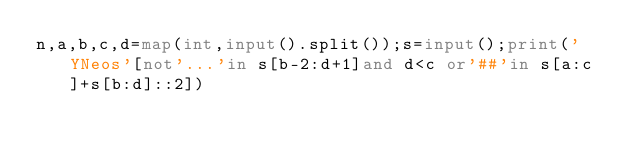Convert code to text. <code><loc_0><loc_0><loc_500><loc_500><_Python_>n,a,b,c,d=map(int,input().split());s=input();print('YNeos'[not'...'in s[b-2:d+1]and d<c or'##'in s[a:c]+s[b:d]::2])</code> 